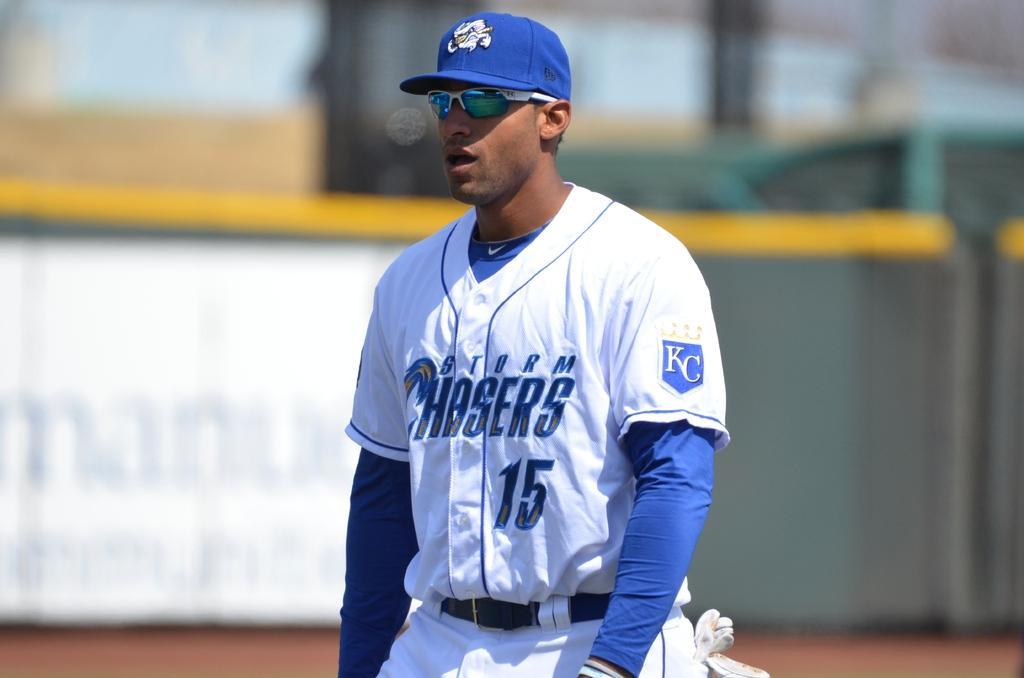<image>
Offer a succinct explanation of the picture presented. A baseball player from the KC Chasers is taking the field with his hat and sunglasses on a bright sunny day. 